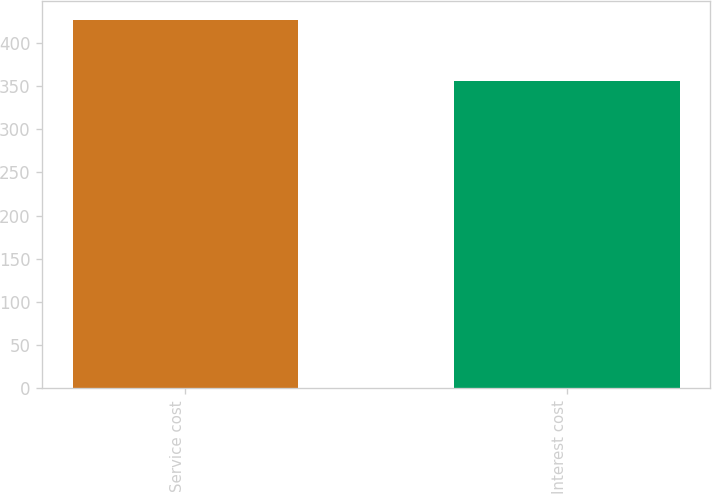Convert chart. <chart><loc_0><loc_0><loc_500><loc_500><bar_chart><fcel>Service cost<fcel>Interest cost<nl><fcel>427<fcel>356<nl></chart> 